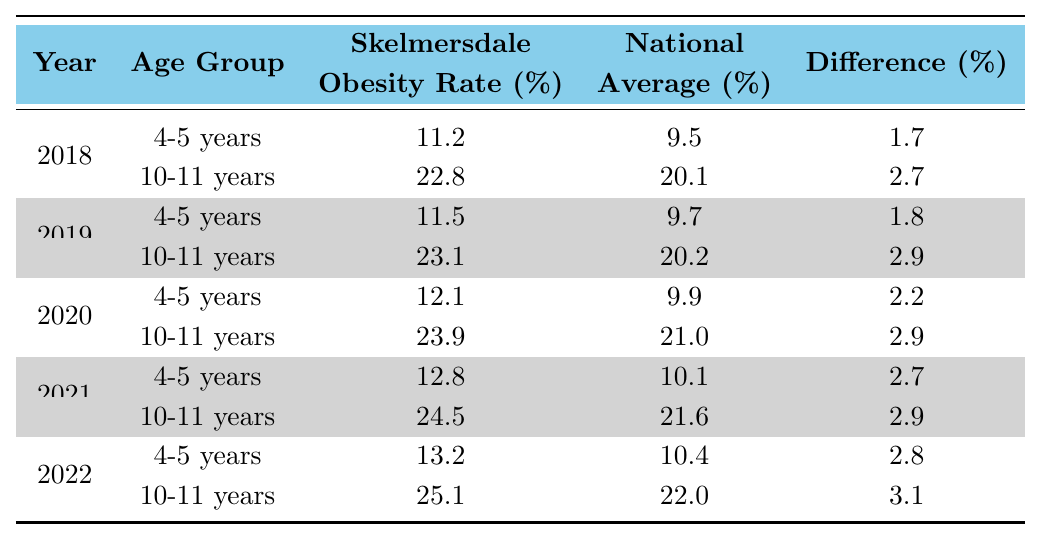What was the Skelmersdale obesity rate for 10-11 year olds in 2020? The table shows that in 2020, the obesity rate for 10-11 year olds in Skelmersdale was 23.9%.
Answer: 23.9% Which year had the highest obesity rate for 4-5 year olds in Skelmersdale? Looking at the table, the highest obesity rate for 4-5 year olds in Skelmersdale was 13.2% in 2022.
Answer: 2022 What is the difference in obesity rates between Skelmersdale and the national average for 10-11 year olds in 2022? The difference in 2022 is calculated as 25.1% (Skelmersdale) - 22.0% (National Average) = 3.1%.
Answer: 3.1% Was there an increase in the obesity rate for 4-5 year olds in Skelmersdale from 2018 to 2022? The obesity rate for 4-5 year olds was 11.2% in 2018 and increased to 13.2% in 2022, indicating an increase.
Answer: Yes What was the average obesity rate for 10-11 year olds in Skelmersdale over the 5 years? The rates for 10-11 year olds from 2018 to 2022 are 22.8%, 23.1%, 23.9%, 24.5%, and 25.1%. The average is (22.8 + 23.1 + 23.9 + 24.5 + 25.1) / 5 = 23.848%.
Answer: 23.85% In which year did Skelmersdale's obesity rate for 10-11 year olds come closest to the national average? Looking at the table, in 2018, the difference was 2.7%, which is the smallest gap compared to other years.
Answer: 2018 Which age group consistently had a higher obesity rate in Skelmersdale compared to the national average over the years? The table indicates that the age group of 10-11 years consistently had a higher obesity rate than the national average throughout the years displayed.
Answer: 10-11 years What is the total increase in the obesity rate for 4-5 year olds in Skelmersdale from 2018 to 2022? The rate in 2018 was 11.2%, and in 2022 it was 13.2%. The increase is 13.2% - 11.2% = 2.0%.
Answer: 2.0% Was there any year where the Skelmersdale obesity rate for 4-5 year olds was lower than the national average? In the years shown, the Skelmersdale obesity rate for 4-5 year olds was always higher than the national average, indicating no year was lower.
Answer: No 